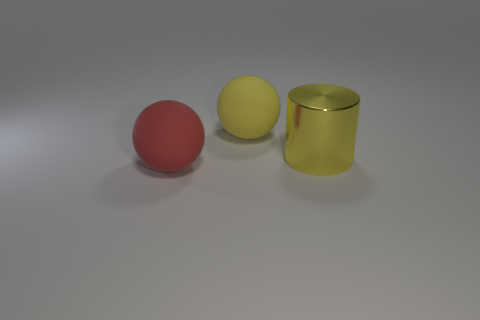Are there the same number of rubber balls behind the shiny cylinder and small gray matte things?
Give a very brief answer. No. What number of objects are either large things that are in front of the big cylinder or big balls?
Your answer should be very brief. 2. Do the large rubber ball behind the large metallic cylinder and the big metallic cylinder have the same color?
Offer a very short reply. Yes. How big is the object in front of the large metal object?
Give a very brief answer. Large. What is the shape of the large yellow object that is in front of the yellow object that is on the left side of the shiny thing?
Ensure brevity in your answer.  Cylinder. There is another object that is the same shape as the red matte object; what is its color?
Keep it short and to the point. Yellow. There is a rubber object on the left side of the yellow ball; does it have the same size as the metal cylinder?
Offer a terse response. Yes. What shape is the large matte thing that is the same color as the metal object?
Provide a short and direct response. Sphere. How many other large yellow cylinders are made of the same material as the cylinder?
Offer a terse response. 0. What material is the object behind the yellow thing in front of the big rubber sphere behind the large red object made of?
Your answer should be compact. Rubber. 